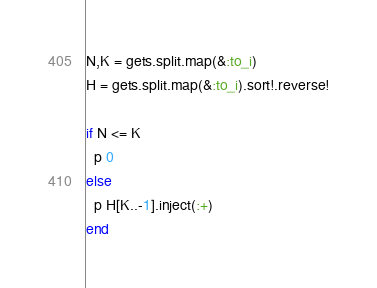<code> <loc_0><loc_0><loc_500><loc_500><_Ruby_>N,K = gets.split.map(&:to_i)
H = gets.split.map(&:to_i).sort!.reverse!

if N <= K
  p 0
else
  p H[K..-1].inject(:+)
end</code> 